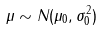<formula> <loc_0><loc_0><loc_500><loc_500>\mu \sim N ( \mu _ { 0 } , \sigma _ { 0 } ^ { 2 } )</formula> 